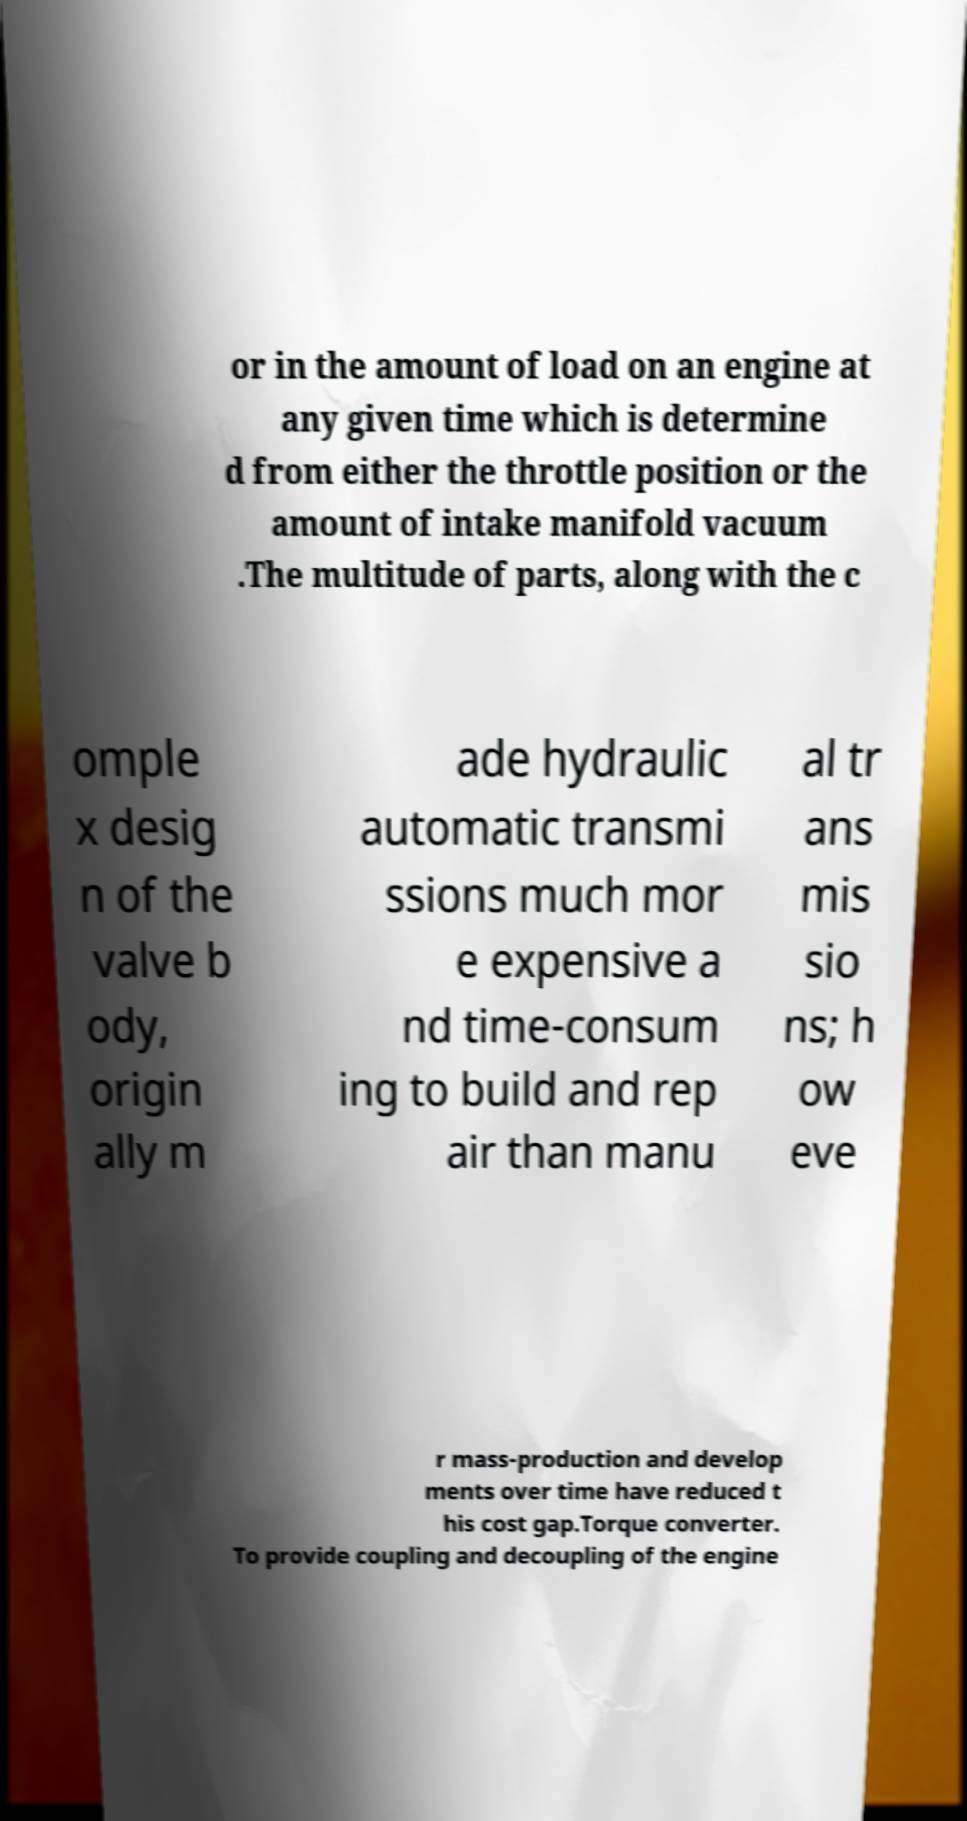Please identify and transcribe the text found in this image. or in the amount of load on an engine at any given time which is determine d from either the throttle position or the amount of intake manifold vacuum .The multitude of parts, along with the c omple x desig n of the valve b ody, origin ally m ade hydraulic automatic transmi ssions much mor e expensive a nd time-consum ing to build and rep air than manu al tr ans mis sio ns; h ow eve r mass-production and develop ments over time have reduced t his cost gap.Torque converter. To provide coupling and decoupling of the engine 